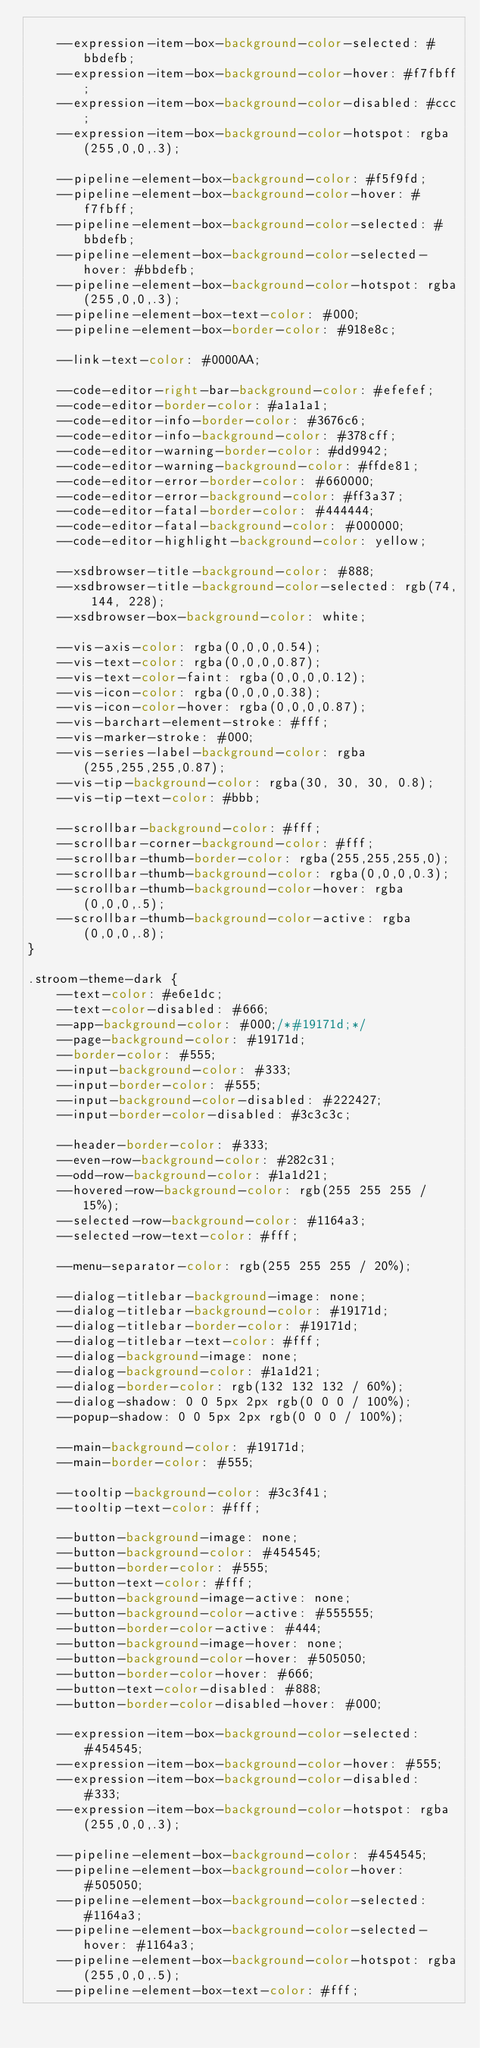Convert code to text. <code><loc_0><loc_0><loc_500><loc_500><_CSS_>
    --expression-item-box-background-color-selected: #bbdefb;
    --expression-item-box-background-color-hover: #f7fbff;
    --expression-item-box-background-color-disabled: #ccc;
    --expression-item-box-background-color-hotspot: rgba(255,0,0,.3);

    --pipeline-element-box-background-color: #f5f9fd;
    --pipeline-element-box-background-color-hover: #f7fbff;
    --pipeline-element-box-background-color-selected: #bbdefb;
    --pipeline-element-box-background-color-selected-hover: #bbdefb;
    --pipeline-element-box-background-color-hotspot: rgba(255,0,0,.3);
    --pipeline-element-box-text-color: #000;
    --pipeline-element-box-border-color: #918e8c;

    --link-text-color: #0000AA;

    --code-editor-right-bar-background-color: #efefef;
    --code-editor-border-color: #a1a1a1;
    --code-editor-info-border-color: #3676c6;
    --code-editor-info-background-color: #378cff;
    --code-editor-warning-border-color: #dd9942;
    --code-editor-warning-background-color: #ffde81;
    --code-editor-error-border-color: #660000;
    --code-editor-error-background-color: #ff3a37;
    --code-editor-fatal-border-color: #444444;
    --code-editor-fatal-background-color: #000000;
    --code-editor-highlight-background-color: yellow;

    --xsdbrowser-title-background-color: #888;
    --xsdbrowser-title-background-color-selected: rgb(74, 144, 228);
    --xsdbrowser-box-background-color: white;

    --vis-axis-color: rgba(0,0,0,0.54);
    --vis-text-color: rgba(0,0,0,0.87);
    --vis-text-color-faint: rgba(0,0,0,0.12);
    --vis-icon-color: rgba(0,0,0,0.38);
    --vis-icon-color-hover: rgba(0,0,0,0.87);
    --vis-barchart-element-stroke: #fff;
    --vis-marker-stroke: #000;
    --vis-series-label-background-color: rgba(255,255,255,0.87);
    --vis-tip-background-color: rgba(30, 30, 30, 0.8);
    --vis-tip-text-color: #bbb;

    --scrollbar-background-color: #fff;
    --scrollbar-corner-background-color: #fff;
    --scrollbar-thumb-border-color: rgba(255,255,255,0);
    --scrollbar-thumb-background-color: rgba(0,0,0,0.3);
    --scrollbar-thumb-background-color-hover: rgba(0,0,0,.5);
    --scrollbar-thumb-background-color-active: rgba(0,0,0,.8);
}

.stroom-theme-dark {
    --text-color: #e6e1dc;
    --text-color-disabled: #666;
    --app-background-color: #000;/*#19171d;*/
    --page-background-color: #19171d;
    --border-color: #555;
    --input-background-color: #333;
    --input-border-color: #555;
    --input-background-color-disabled: #222427;
    --input-border-color-disabled: #3c3c3c;

    --header-border-color: #333;
    --even-row-background-color: #282c31;
    --odd-row-background-color: #1a1d21;
    --hovered-row-background-color: rgb(255 255 255 / 15%);
    --selected-row-background-color: #1164a3;
    --selected-row-text-color: #fff;

    --menu-separator-color: rgb(255 255 255 / 20%);

    --dialog-titlebar-background-image: none;
    --dialog-titlebar-background-color: #19171d;
    --dialog-titlebar-border-color: #19171d;
    --dialog-titlebar-text-color: #fff;
    --dialog-background-image: none;
    --dialog-background-color: #1a1d21;
    --dialog-border-color: rgb(132 132 132 / 60%);
    --dialog-shadow: 0 0 5px 2px rgb(0 0 0 / 100%);
    --popup-shadow: 0 0 5px 2px rgb(0 0 0 / 100%);

    --main-background-color: #19171d;
    --main-border-color: #555;

    --tooltip-background-color: #3c3f41;
    --tooltip-text-color: #fff;

    --button-background-image: none;
    --button-background-color: #454545;
    --button-border-color: #555;
    --button-text-color: #fff;
    --button-background-image-active: none;
    --button-background-color-active: #555555;
    --button-border-color-active: #444;
    --button-background-image-hover: none;
    --button-background-color-hover: #505050;
    --button-border-color-hover: #666;
    --button-text-color-disabled: #888;
    --button-border-color-disabled-hover: #000;

    --expression-item-box-background-color-selected: #454545;
    --expression-item-box-background-color-hover: #555;
    --expression-item-box-background-color-disabled: #333;
    --expression-item-box-background-color-hotspot: rgba(255,0,0,.3);

    --pipeline-element-box-background-color: #454545;
    --pipeline-element-box-background-color-hover: #505050;
    --pipeline-element-box-background-color-selected: #1164a3;
    --pipeline-element-box-background-color-selected-hover: #1164a3;
    --pipeline-element-box-background-color-hotspot: rgba(255,0,0,.5);
    --pipeline-element-box-text-color: #fff;</code> 